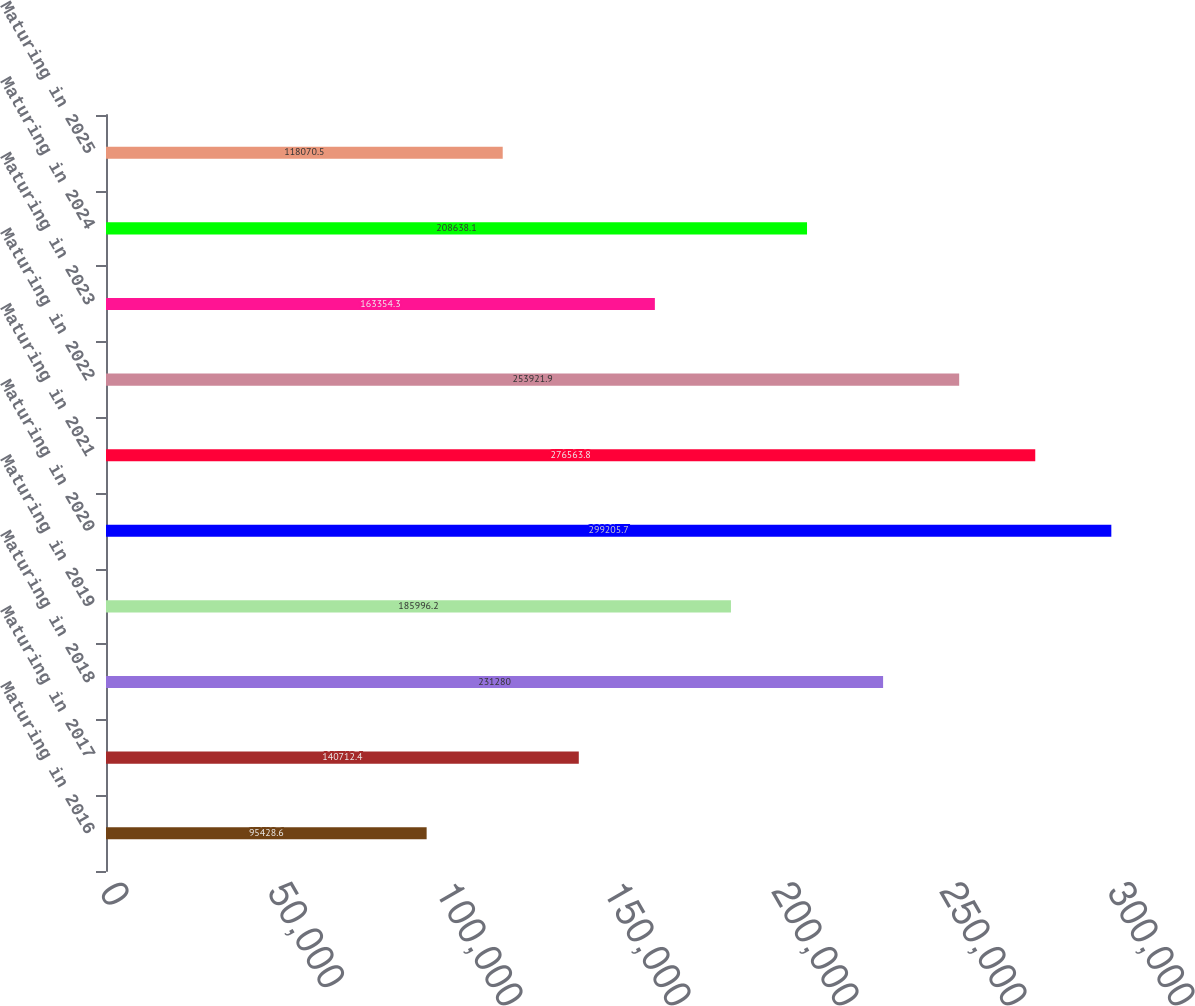Convert chart to OTSL. <chart><loc_0><loc_0><loc_500><loc_500><bar_chart><fcel>Maturing in 2016<fcel>Maturing in 2017<fcel>Maturing in 2018<fcel>Maturing in 2019<fcel>Maturing in 2020<fcel>Maturing in 2021<fcel>Maturing in 2022<fcel>Maturing in 2023<fcel>Maturing in 2024<fcel>Maturing in 2025<nl><fcel>95428.6<fcel>140712<fcel>231280<fcel>185996<fcel>299206<fcel>276564<fcel>253922<fcel>163354<fcel>208638<fcel>118070<nl></chart> 